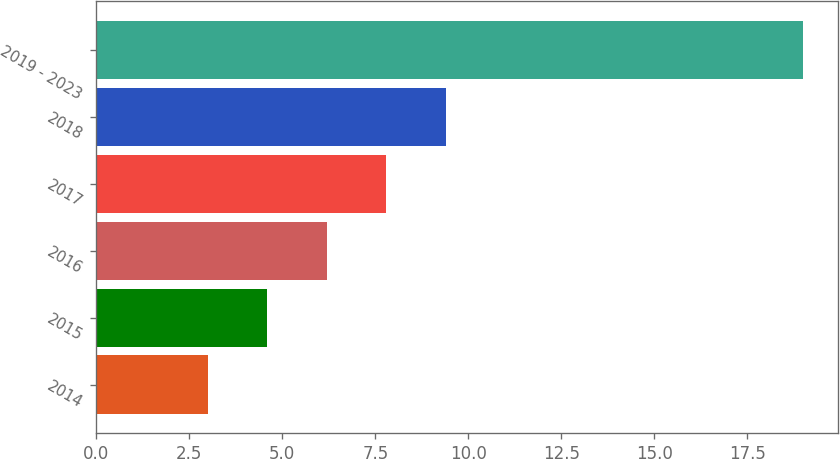Convert chart to OTSL. <chart><loc_0><loc_0><loc_500><loc_500><bar_chart><fcel>2014<fcel>2015<fcel>2016<fcel>2017<fcel>2018<fcel>2019 - 2023<nl><fcel>3<fcel>4.6<fcel>6.2<fcel>7.8<fcel>9.4<fcel>19<nl></chart> 